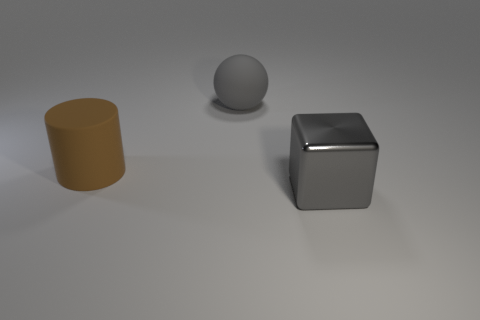Add 2 large gray balls. How many objects exist? 5 Subtract all cubes. How many objects are left? 2 Add 1 rubber cylinders. How many rubber cylinders exist? 2 Subtract 0 brown spheres. How many objects are left? 3 Subtract all large cylinders. Subtract all large gray things. How many objects are left? 0 Add 1 metallic cubes. How many metallic cubes are left? 2 